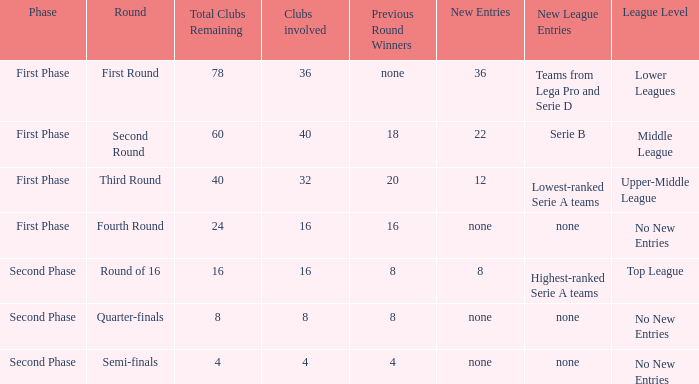Help me parse the entirety of this table. {'header': ['Phase', 'Round', 'Total Clubs Remaining', 'Clubs involved', 'Previous Round Winners', 'New Entries', 'New League Entries', 'League Level'], 'rows': [['First Phase', 'First Round', '78', '36', 'none', '36', 'Teams from Lega Pro and Serie D', 'Lower Leagues'], ['First Phase', 'Second Round', '60', '40', '18', '22', 'Serie B', 'Middle League'], ['First Phase', 'Third Round', '40', '32', '20', '12', 'Lowest-ranked Serie A teams', 'Upper-Middle League'], ['First Phase', 'Fourth Round', '24', '16', '16', 'none', 'none', 'No New Entries'], ['Second Phase', 'Round of 16', '16', '16', '8', '8', 'Highest-ranked Serie A teams', 'Top League'], ['Second Phase', 'Quarter-finals', '8', '8', '8', 'none', 'none', 'No New Entries'], ['Second Phase', 'Semi-finals', '4', '4', '4', 'none', 'none', 'No New Entries']]} Considering 8 clubs are taking part, what numerical value can be obtained from the winners in the last round? 8.0. 